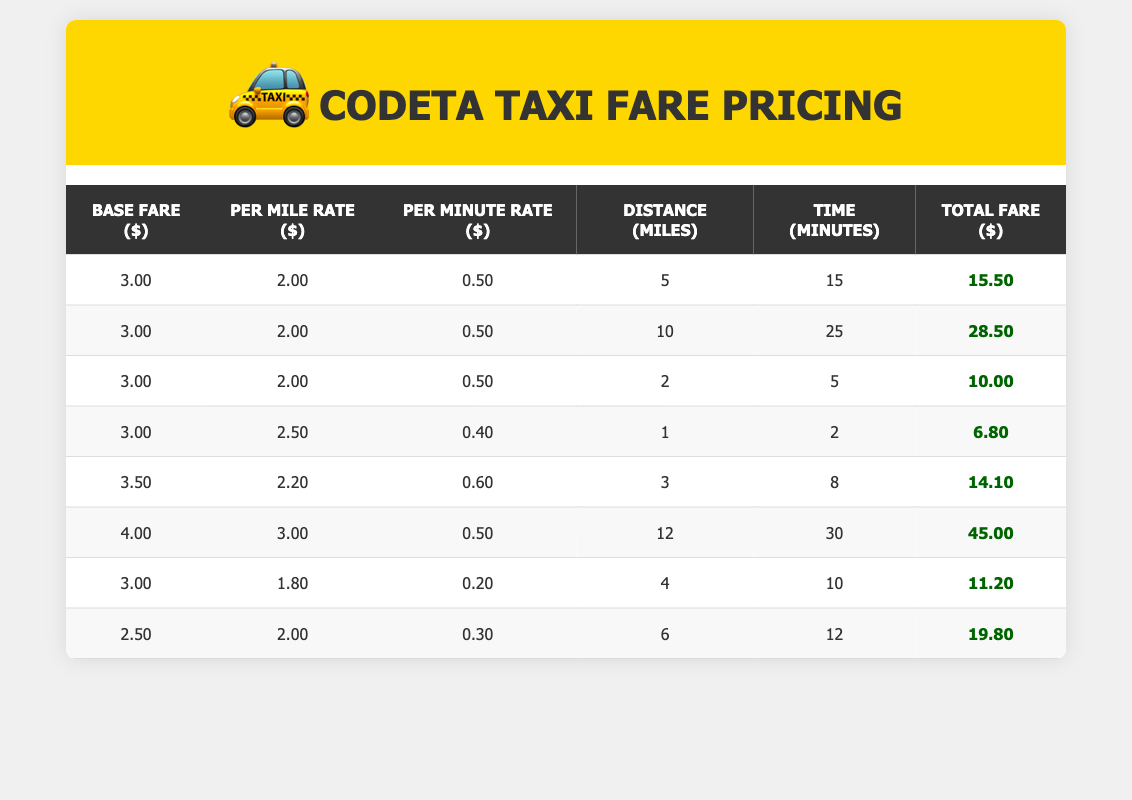What is the base fare for the longest trip listed? The longest trip listed is 12 miles. Referring to the row with 12 miles, the base fare is 4.0.
Answer: 4.0 How much is the total fare for a trip of 6 miles with a per mile rate of 2.0 and a per minute rate of 0.3 over 12 minutes? The base fare for this scenario from the table is 2.5, the total fare is calculated as follows: base fare (2.5) + (per mile rate (2.0) * distance (6)) + (per minute rate (0.3) * time (12)) = 2.5 + 12 + 3.6 = 18.1.
Answer: 18.1 Is the total fare higher than 15 for a 5-mile trip? Looking up the 5-mile trip in the table, the total fare is 15.5 which is greater than 15.
Answer: Yes What is the average fare for trips that are 10 miles or longer? The fares for trips that are 10 miles or longer are 28.5 (10 miles) and 45.0 (12 miles). Adding these gives 28.5 + 45.0 = 73.5. The total number of trips in this category is 2, thus the average fare is 73.5 divided by 2, which is 36.75.
Answer: 36.75 What is the per minute rate for the 3-mile trip? The 3-mile trip has a per minute rate of 0.6. This can be found directly in the trip data associated with 3 miles.
Answer: 0.6 Which trip has the lowest total fare, and what is that fare? The trip with the lowest total fare is the 1-mile trip listed with a total fare of 6.8. This can be determined by scanning the total fare column for the minimum value.
Answer: 6.8 